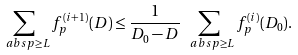Convert formula to latex. <formula><loc_0><loc_0><loc_500><loc_500>\sum _ { \ a b s { p } \geq L } f _ { p } ^ { ( i + 1 ) } ( D ) \leq \frac { 1 } { D _ { 0 } - D } \sum _ { \ a b s { p } \geq L } f _ { p } ^ { ( i ) } ( D _ { 0 } ) .</formula> 